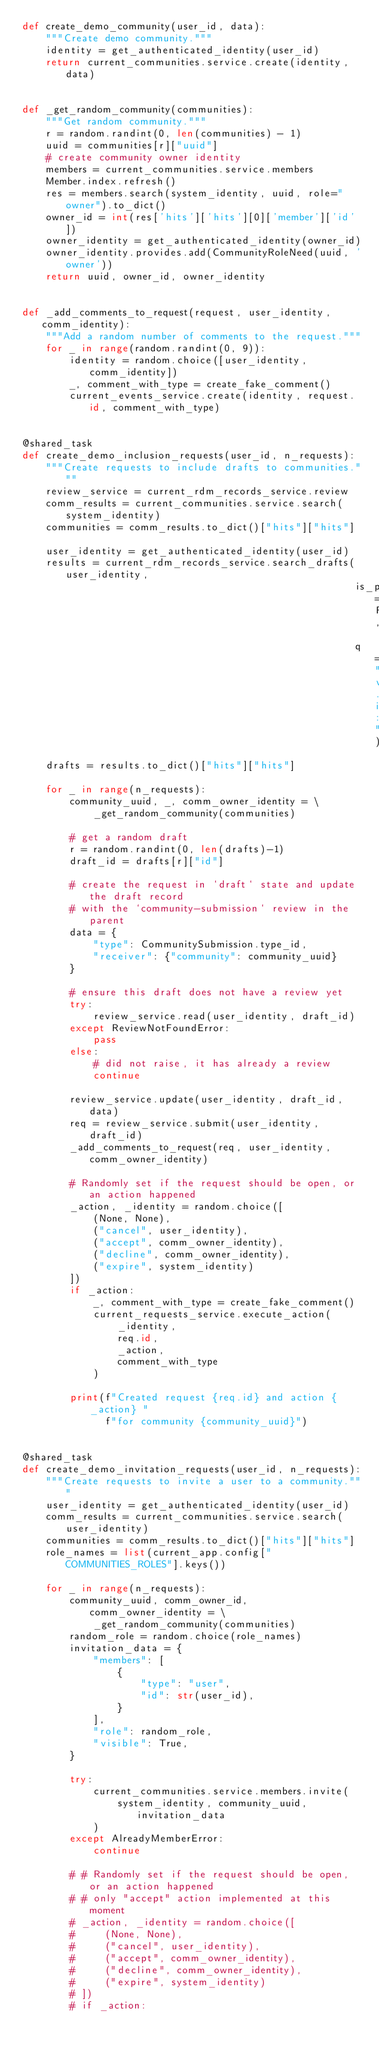Convert code to text. <code><loc_0><loc_0><loc_500><loc_500><_Python_>def create_demo_community(user_id, data):
    """Create demo community."""
    identity = get_authenticated_identity(user_id)
    return current_communities.service.create(identity, data)


def _get_random_community(communities):
    """Get random community."""
    r = random.randint(0, len(communities) - 1)
    uuid = communities[r]["uuid"]
    # create community owner identity
    members = current_communities.service.members
    Member.index.refresh()
    res = members.search(system_identity, uuid, role="owner").to_dict()
    owner_id = int(res['hits']['hits'][0]['member']['id'])
    owner_identity = get_authenticated_identity(owner_id)
    owner_identity.provides.add(CommunityRoleNeed(uuid, 'owner'))
    return uuid, owner_id, owner_identity


def _add_comments_to_request(request, user_identity, comm_identity):
    """Add a random number of comments to the request."""
    for _ in range(random.randint(0, 9)):
        identity = random.choice([user_identity, comm_identity])
        _, comment_with_type = create_fake_comment()
        current_events_service.create(identity, request.id, comment_with_type)


@shared_task
def create_demo_inclusion_requests(user_id, n_requests):
    """Create requests to include drafts to communities."""
    review_service = current_rdm_records_service.review
    comm_results = current_communities.service.search(system_identity)
    communities = comm_results.to_dict()["hits"]["hits"]

    user_identity = get_authenticated_identity(user_id)
    results = current_rdm_records_service.search_drafts(user_identity,
                                                        is_published=False,
                                                        q="versions.index:1")
    drafts = results.to_dict()["hits"]["hits"]

    for _ in range(n_requests):
        community_uuid, _, comm_owner_identity = \
            _get_random_community(communities)

        # get a random draft
        r = random.randint(0, len(drafts)-1)
        draft_id = drafts[r]["id"]

        # create the request in `draft` state and update the draft record
        # with the `community-submission` review in the parent
        data = {
            "type": CommunitySubmission.type_id,
            "receiver": {"community": community_uuid}
        }

        # ensure this draft does not have a review yet
        try:
            review_service.read(user_identity, draft_id)
        except ReviewNotFoundError:
            pass
        else:
            # did not raise, it has already a review
            continue

        review_service.update(user_identity, draft_id, data)
        req = review_service.submit(user_identity, draft_id)
        _add_comments_to_request(req, user_identity, comm_owner_identity)

        # Randomly set if the request should be open, or an action happened
        _action, _identity = random.choice([
            (None, None),
            ("cancel", user_identity),
            ("accept", comm_owner_identity),
            ("decline", comm_owner_identity),
            ("expire", system_identity)
        ])
        if _action:
            _, comment_with_type = create_fake_comment()
            current_requests_service.execute_action(
                _identity,
                req.id,
                _action,
                comment_with_type
            )

        print(f"Created request {req.id} and action {_action} "
              f"for community {community_uuid}")


@shared_task
def create_demo_invitation_requests(user_id, n_requests):
    """Create requests to invite a user to a community."""
    user_identity = get_authenticated_identity(user_id)
    comm_results = current_communities.service.search(user_identity)
    communities = comm_results.to_dict()["hits"]["hits"]
    role_names = list(current_app.config["COMMUNITIES_ROLES"].keys())

    for _ in range(n_requests):
        community_uuid, comm_owner_id, comm_owner_identity = \
            _get_random_community(communities)
        random_role = random.choice(role_names)
        invitation_data = {
            "members": [
                {
                    "type": "user",
                    "id": str(user_id),
                }
            ],
            "role": random_role,
            "visible": True,
        }

        try:
            current_communities.service.members.invite(
                system_identity, community_uuid, invitation_data
            )
        except AlreadyMemberError:
            continue

        # # Randomly set if the request should be open, or an action happened
        # # only "accept" action implemented at this moment
        # _action, _identity = random.choice([
        #     (None, None),
        #     ("cancel", user_identity),
        #     ("accept", comm_owner_identity),
        #     ("decline", comm_owner_identity),
        #     ("expire", system_identity)
        # ])
        # if _action:</code> 